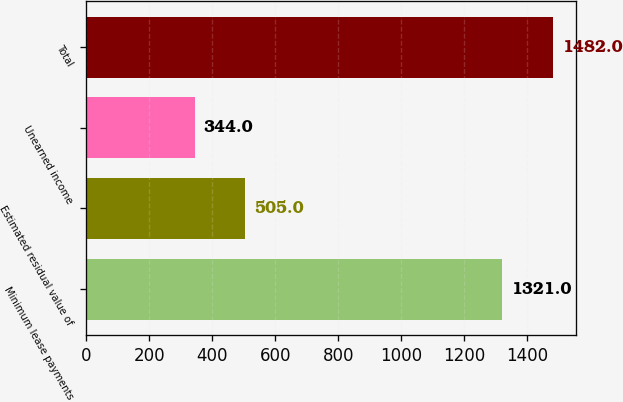Convert chart. <chart><loc_0><loc_0><loc_500><loc_500><bar_chart><fcel>Minimum lease payments<fcel>Estimated residual value of<fcel>Unearned income<fcel>Total<nl><fcel>1321<fcel>505<fcel>344<fcel>1482<nl></chart> 